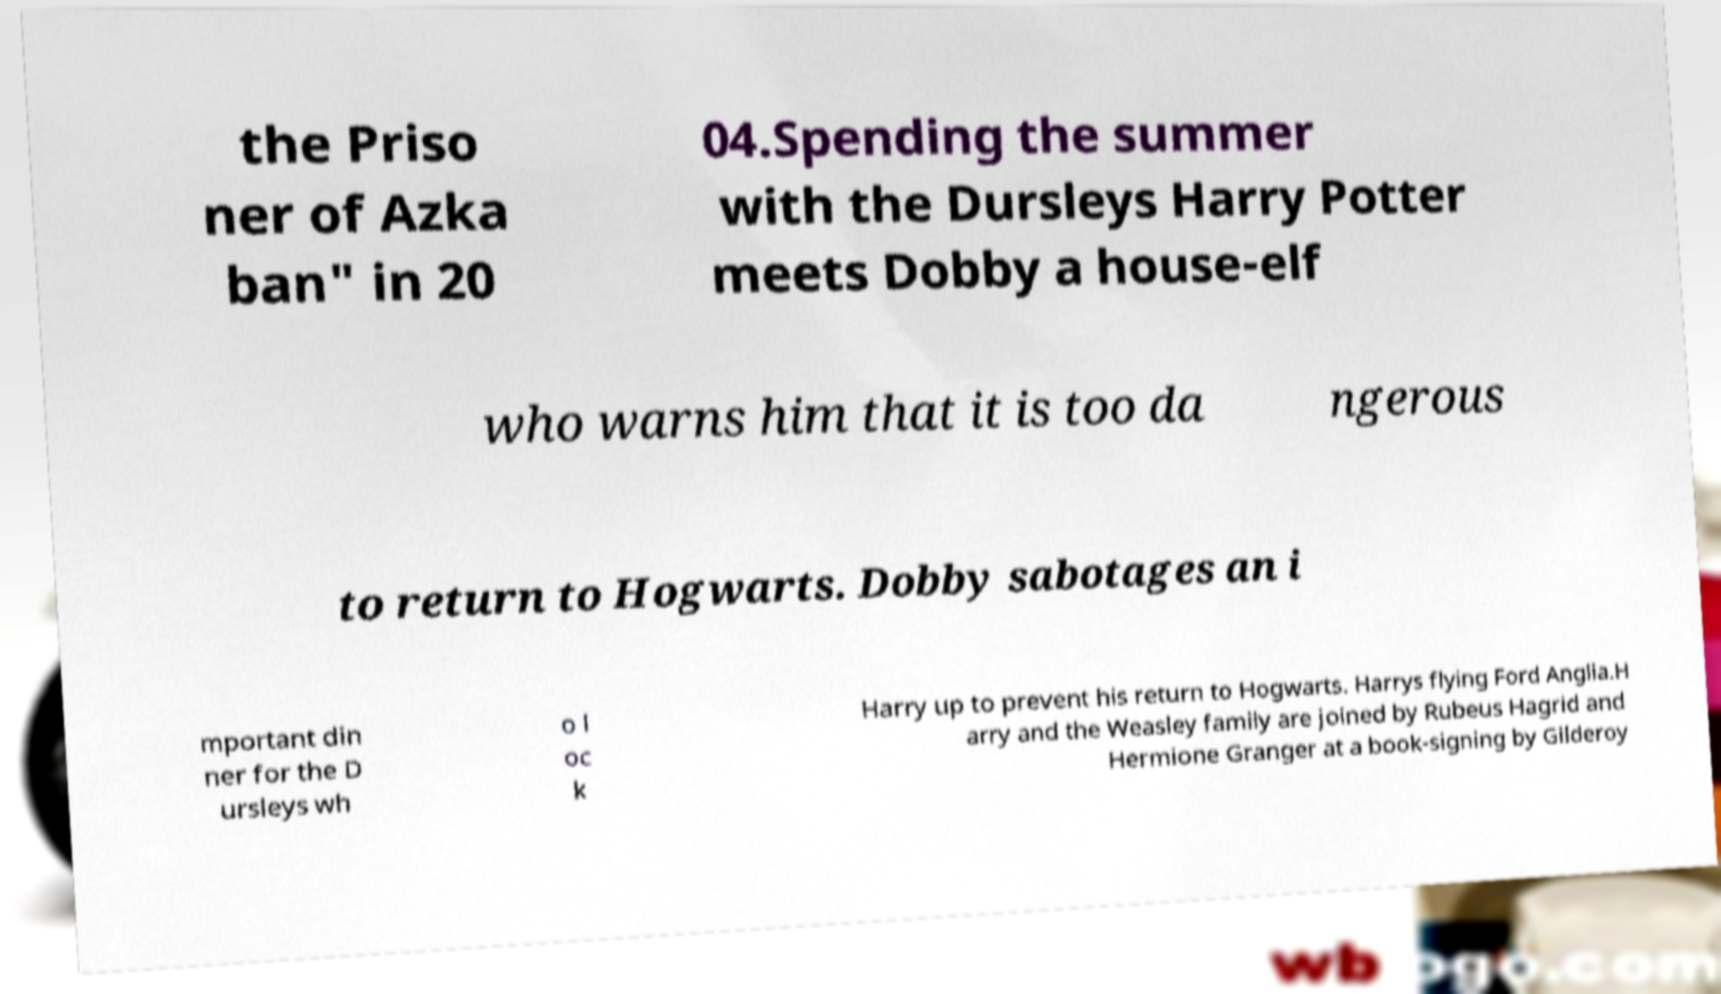Please read and relay the text visible in this image. What does it say? the Priso ner of Azka ban" in 20 04.Spending the summer with the Dursleys Harry Potter meets Dobby a house-elf who warns him that it is too da ngerous to return to Hogwarts. Dobby sabotages an i mportant din ner for the D ursleys wh o l oc k Harry up to prevent his return to Hogwarts. Harrys flying Ford Anglia.H arry and the Weasley family are joined by Rubeus Hagrid and Hermione Granger at a book-signing by Gilderoy 